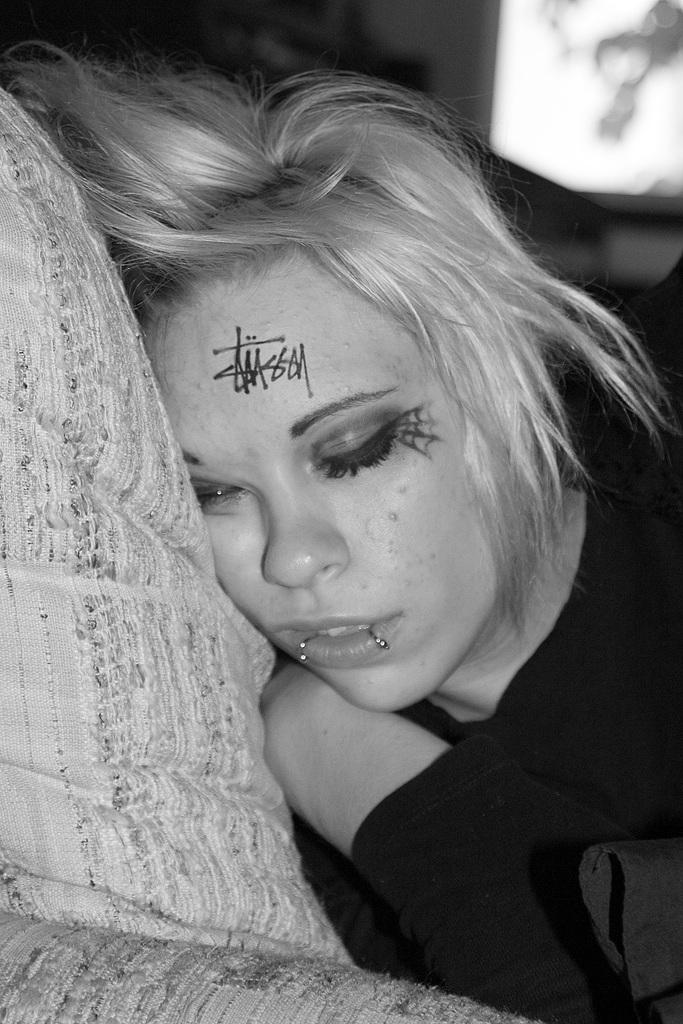Who is the main subject in the image? There is a woman in the image. What is the woman doing in the image? The woman is laying on a pillow. What is the woman wearing in the image? The woman is wearing a black dress. What is unique about the woman's appearance in the image? There is a painting on her face. What type of thread is being used to transport the town in the image? There is no thread, town, or transport present in the image. 